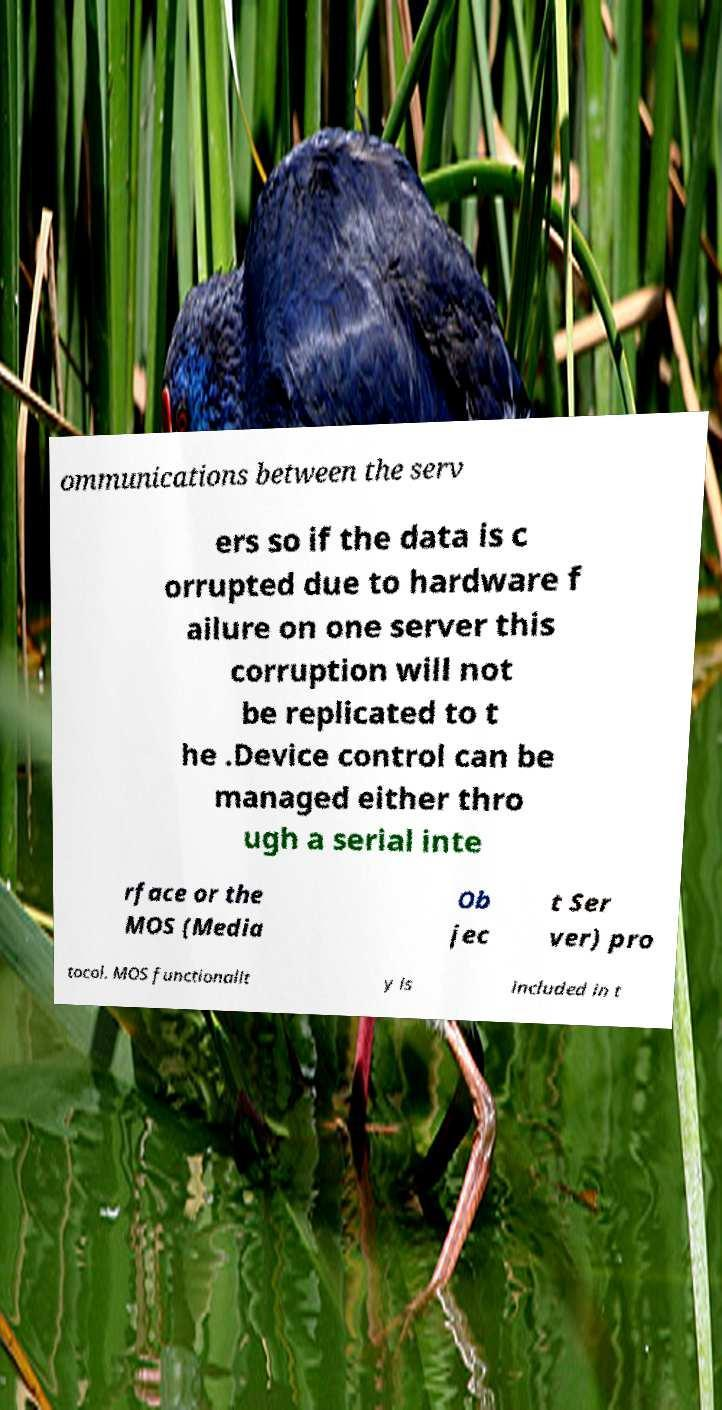Could you assist in decoding the text presented in this image and type it out clearly? ommunications between the serv ers so if the data is c orrupted due to hardware f ailure on one server this corruption will not be replicated to t he .Device control can be managed either thro ugh a serial inte rface or the MOS (Media Ob jec t Ser ver) pro tocol. MOS functionalit y is included in t 